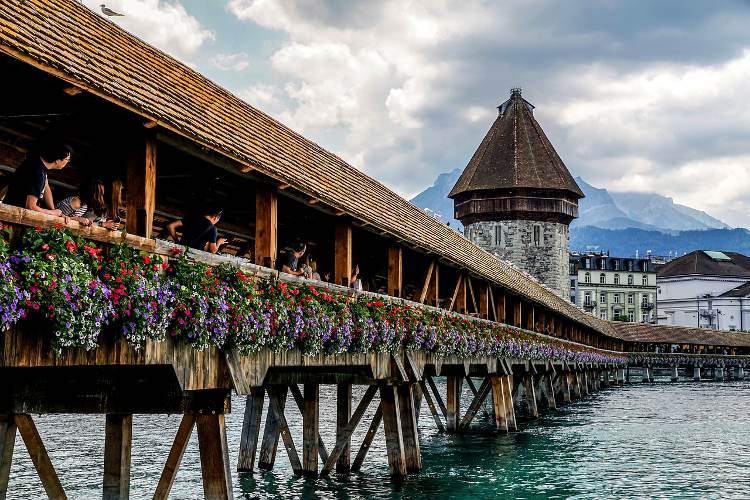What do you think is going on in this snapshot? This snapshot beautifully depicts the historic Chapel Bridge in Lucerne, Switzerland, renowned for being one of the oldest wooden bridges in Europe. The bridge, adorned with vibrant flowers, spans the Reuss River, with its architectural glory highlighted by the famous Water Tower which once served as part of the city's defenses. The bustling activity visible on the bridge indicates its popularity as a tourist attraction, while the Alps provide a breathtaking backdrop, signifying the bridge's melding of natural and cultural heritage. 